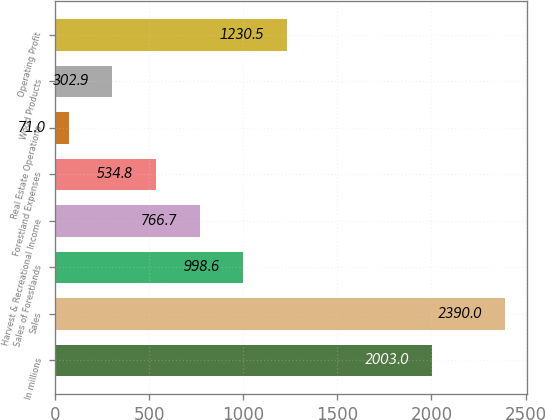Convert chart. <chart><loc_0><loc_0><loc_500><loc_500><bar_chart><fcel>In millions<fcel>Sales<fcel>Sales of Forestlands<fcel>Harvest & Recreational Income<fcel>Forestland Expenses<fcel>Real Estate Operations<fcel>Wood Products<fcel>Operating Profit<nl><fcel>2003<fcel>2390<fcel>998.6<fcel>766.7<fcel>534.8<fcel>71<fcel>302.9<fcel>1230.5<nl></chart> 